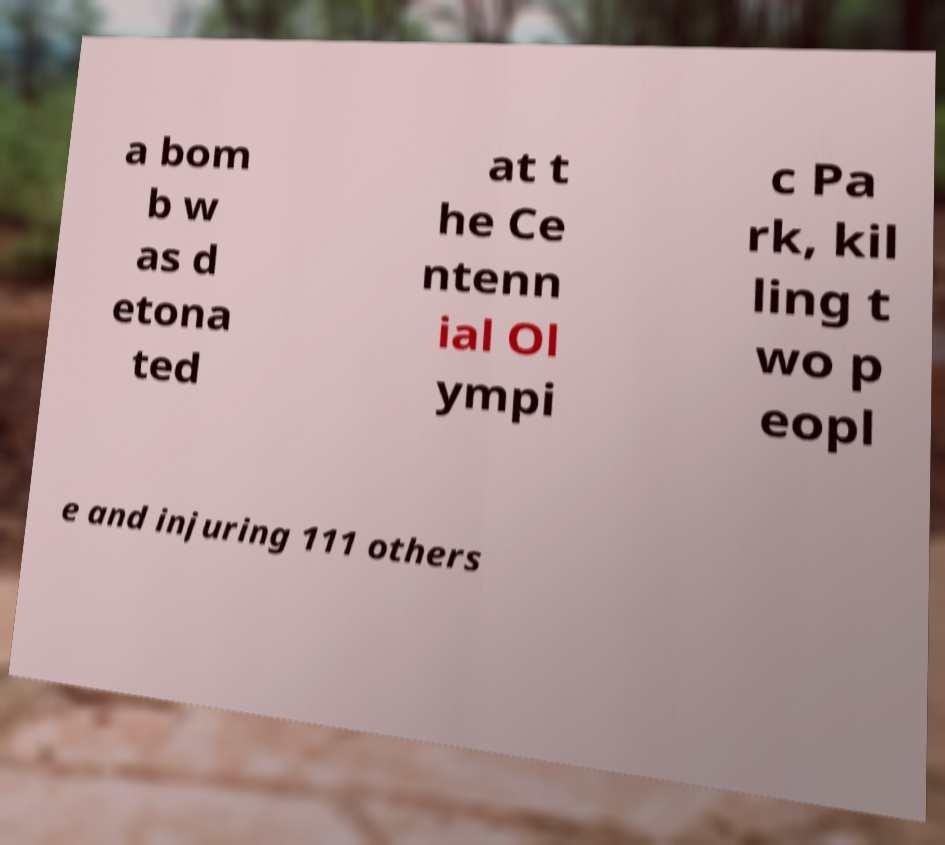What messages or text are displayed in this image? I need them in a readable, typed format. a bom b w as d etona ted at t he Ce ntenn ial Ol ympi c Pa rk, kil ling t wo p eopl e and injuring 111 others 